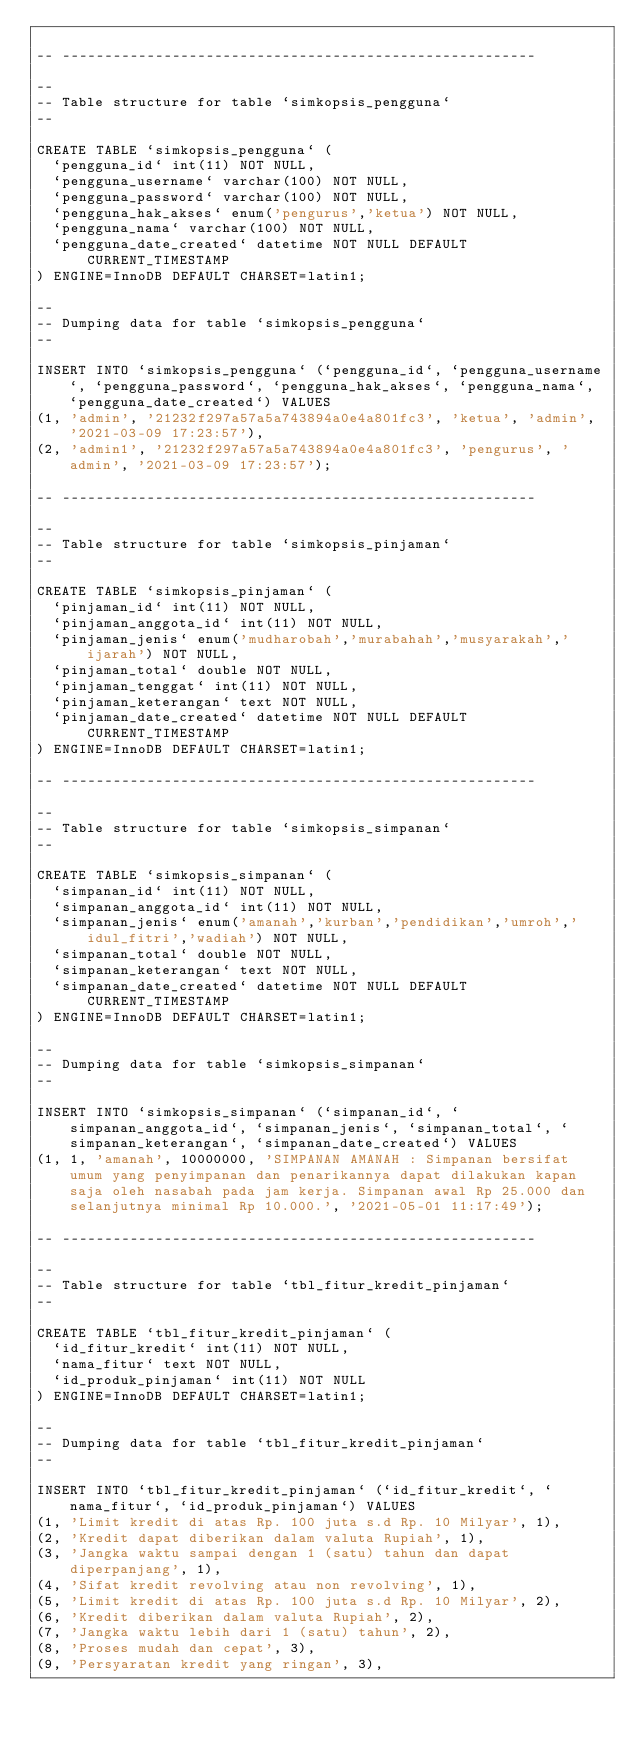<code> <loc_0><loc_0><loc_500><loc_500><_SQL_>
-- --------------------------------------------------------

--
-- Table structure for table `simkopsis_pengguna`
--

CREATE TABLE `simkopsis_pengguna` (
  `pengguna_id` int(11) NOT NULL,
  `pengguna_username` varchar(100) NOT NULL,
  `pengguna_password` varchar(100) NOT NULL,
  `pengguna_hak_akses` enum('pengurus','ketua') NOT NULL,
  `pengguna_nama` varchar(100) NOT NULL,
  `pengguna_date_created` datetime NOT NULL DEFAULT CURRENT_TIMESTAMP
) ENGINE=InnoDB DEFAULT CHARSET=latin1;

--
-- Dumping data for table `simkopsis_pengguna`
--

INSERT INTO `simkopsis_pengguna` (`pengguna_id`, `pengguna_username`, `pengguna_password`, `pengguna_hak_akses`, `pengguna_nama`, `pengguna_date_created`) VALUES
(1, 'admin', '21232f297a57a5a743894a0e4a801fc3', 'ketua', 'admin', '2021-03-09 17:23:57'),
(2, 'admin1', '21232f297a57a5a743894a0e4a801fc3', 'pengurus', 'admin', '2021-03-09 17:23:57');

-- --------------------------------------------------------

--
-- Table structure for table `simkopsis_pinjaman`
--

CREATE TABLE `simkopsis_pinjaman` (
  `pinjaman_id` int(11) NOT NULL,
  `pinjaman_anggota_id` int(11) NOT NULL,
  `pinjaman_jenis` enum('mudharobah','murabahah','musyarakah','ijarah') NOT NULL,
  `pinjaman_total` double NOT NULL,
  `pinjaman_tenggat` int(11) NOT NULL,
  `pinjaman_keterangan` text NOT NULL,
  `pinjaman_date_created` datetime NOT NULL DEFAULT CURRENT_TIMESTAMP
) ENGINE=InnoDB DEFAULT CHARSET=latin1;

-- --------------------------------------------------------

--
-- Table structure for table `simkopsis_simpanan`
--

CREATE TABLE `simkopsis_simpanan` (
  `simpanan_id` int(11) NOT NULL,
  `simpanan_anggota_id` int(11) NOT NULL,
  `simpanan_jenis` enum('amanah','kurban','pendidikan','umroh','idul_fitri','wadiah') NOT NULL,
  `simpanan_total` double NOT NULL,
  `simpanan_keterangan` text NOT NULL,
  `simpanan_date_created` datetime NOT NULL DEFAULT CURRENT_TIMESTAMP
) ENGINE=InnoDB DEFAULT CHARSET=latin1;

--
-- Dumping data for table `simkopsis_simpanan`
--

INSERT INTO `simkopsis_simpanan` (`simpanan_id`, `simpanan_anggota_id`, `simpanan_jenis`, `simpanan_total`, `simpanan_keterangan`, `simpanan_date_created`) VALUES
(1, 1, 'amanah', 10000000, 'SIMPANAN AMANAH : Simpanan bersifat umum yang penyimpanan dan penarikannya dapat dilakukan kapan saja oleh nasabah pada jam kerja. Simpanan awal Rp 25.000 dan selanjutnya minimal Rp 10.000.', '2021-05-01 11:17:49');

-- --------------------------------------------------------

--
-- Table structure for table `tbl_fitur_kredit_pinjaman`
--

CREATE TABLE `tbl_fitur_kredit_pinjaman` (
  `id_fitur_kredit` int(11) NOT NULL,
  `nama_fitur` text NOT NULL,
  `id_produk_pinjaman` int(11) NOT NULL
) ENGINE=InnoDB DEFAULT CHARSET=latin1;

--
-- Dumping data for table `tbl_fitur_kredit_pinjaman`
--

INSERT INTO `tbl_fitur_kredit_pinjaman` (`id_fitur_kredit`, `nama_fitur`, `id_produk_pinjaman`) VALUES
(1, 'Limit kredit di atas Rp. 100 juta s.d Rp. 10 Milyar', 1),
(2, 'Kredit dapat diberikan dalam valuta Rupiah', 1),
(3, 'Jangka waktu sampai dengan 1 (satu) tahun dan dapat diperpanjang', 1),
(4, 'Sifat kredit revolving atau non revolving', 1),
(5, 'Limit kredit di atas Rp. 100 juta s.d Rp. 10 Milyar', 2),
(6, 'Kredit diberikan dalam valuta Rupiah', 2),
(7, 'Jangka waktu lebih dari 1 (satu) tahun', 2),
(8, 'Proses mudah dan cepat', 3),
(9, 'Persyaratan kredit yang ringan', 3),</code> 